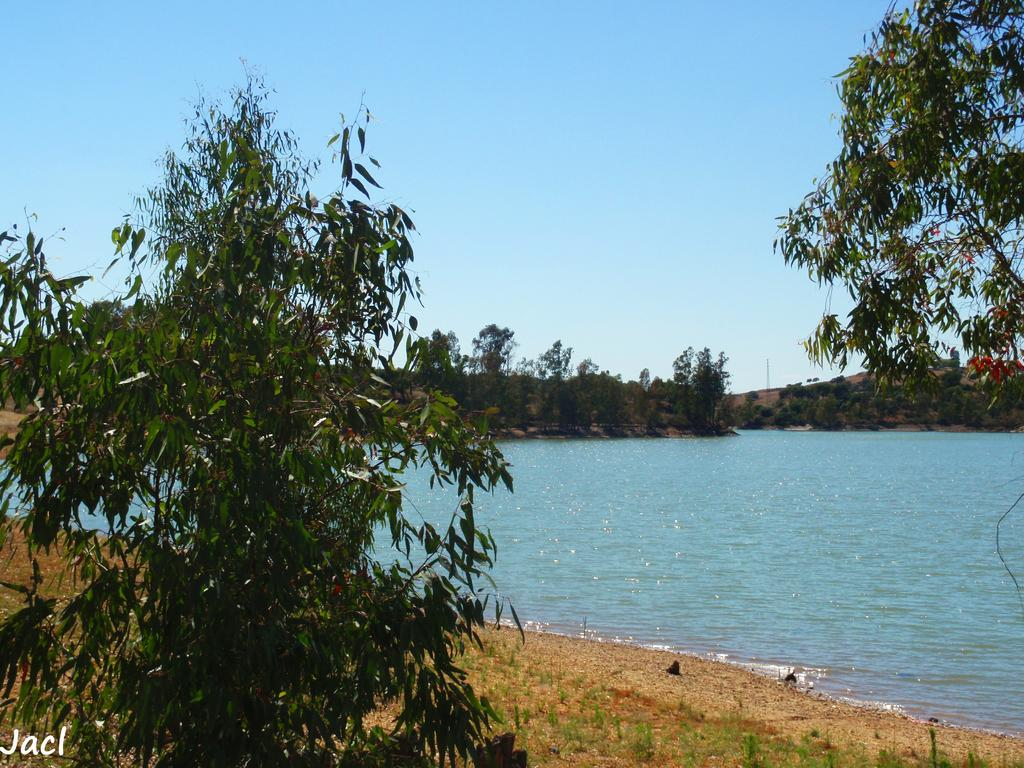What type of vegetation can be seen in the image? There are trees in the image. What natural element is visible in the image? There is water visible in the image. What type of ground cover is present in the image? There is grass in the image. What is visible in the background of the image? The sky is visible in the image. What type of disease is affecting the trees in the image? There is no indication of any disease affecting the trees in the image; they appear healthy. What type of spark can be seen in the image? There is no spark present in the image. 